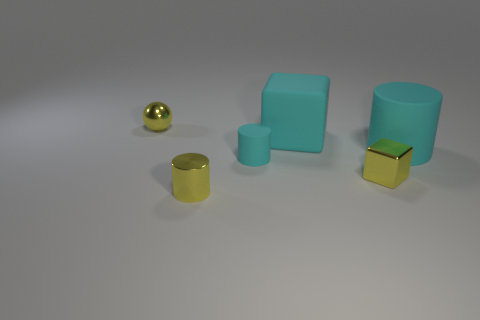Subtract all brown balls. How many cyan cylinders are left? 2 Subtract all big cyan cylinders. How many cylinders are left? 2 Add 2 small balls. How many objects exist? 8 Subtract 1 cylinders. How many cylinders are left? 2 Add 5 spheres. How many spheres are left? 6 Add 4 small purple metallic cubes. How many small purple metallic cubes exist? 4 Subtract 0 gray cylinders. How many objects are left? 6 Subtract all blocks. How many objects are left? 4 Subtract all gray cylinders. Subtract all blue spheres. How many cylinders are left? 3 Subtract all tiny yellow things. Subtract all blue shiny objects. How many objects are left? 3 